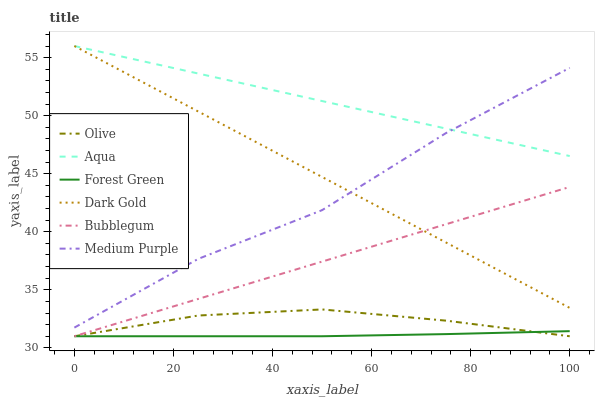Does Forest Green have the minimum area under the curve?
Answer yes or no. Yes. Does Aqua have the maximum area under the curve?
Answer yes or no. Yes. Does Bubblegum have the minimum area under the curve?
Answer yes or no. No. Does Bubblegum have the maximum area under the curve?
Answer yes or no. No. Is Dark Gold the smoothest?
Answer yes or no. Yes. Is Medium Purple the roughest?
Answer yes or no. Yes. Is Bubblegum the smoothest?
Answer yes or no. No. Is Bubblegum the roughest?
Answer yes or no. No. Does Bubblegum have the lowest value?
Answer yes or no. Yes. Does Aqua have the lowest value?
Answer yes or no. No. Does Aqua have the highest value?
Answer yes or no. Yes. Does Bubblegum have the highest value?
Answer yes or no. No. Is Forest Green less than Dark Gold?
Answer yes or no. Yes. Is Aqua greater than Forest Green?
Answer yes or no. Yes. Does Bubblegum intersect Dark Gold?
Answer yes or no. Yes. Is Bubblegum less than Dark Gold?
Answer yes or no. No. Is Bubblegum greater than Dark Gold?
Answer yes or no. No. Does Forest Green intersect Dark Gold?
Answer yes or no. No. 